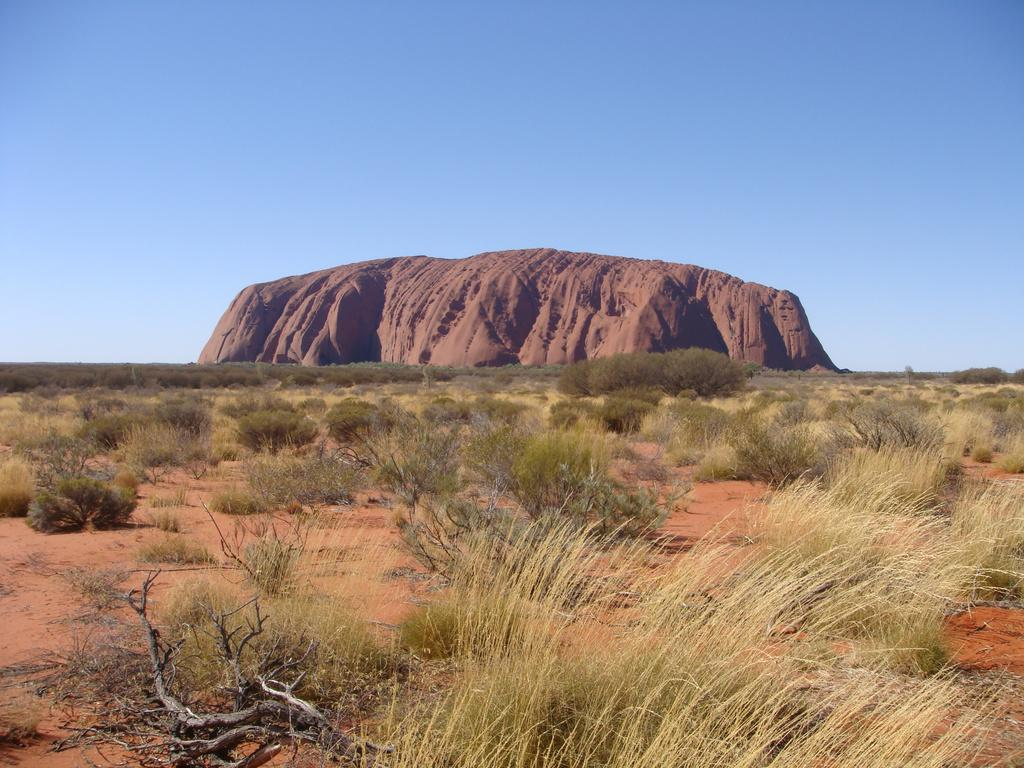What type of objects can be seen in the image? There are wooden sticks in the image. What type of vegetation is present in the image? Grass, plants, and trees are visible in the image. What type of natural landform is visible in the image? There is a mountain in the image. What part of the natural environment is visible in the background of the image? The sky is visible in the background of the image. What type of apparel is being worn by the mountain in the image? There is no apparel present in the image, as the mountain is a natural landform and not a person or object that can wear clothing. 